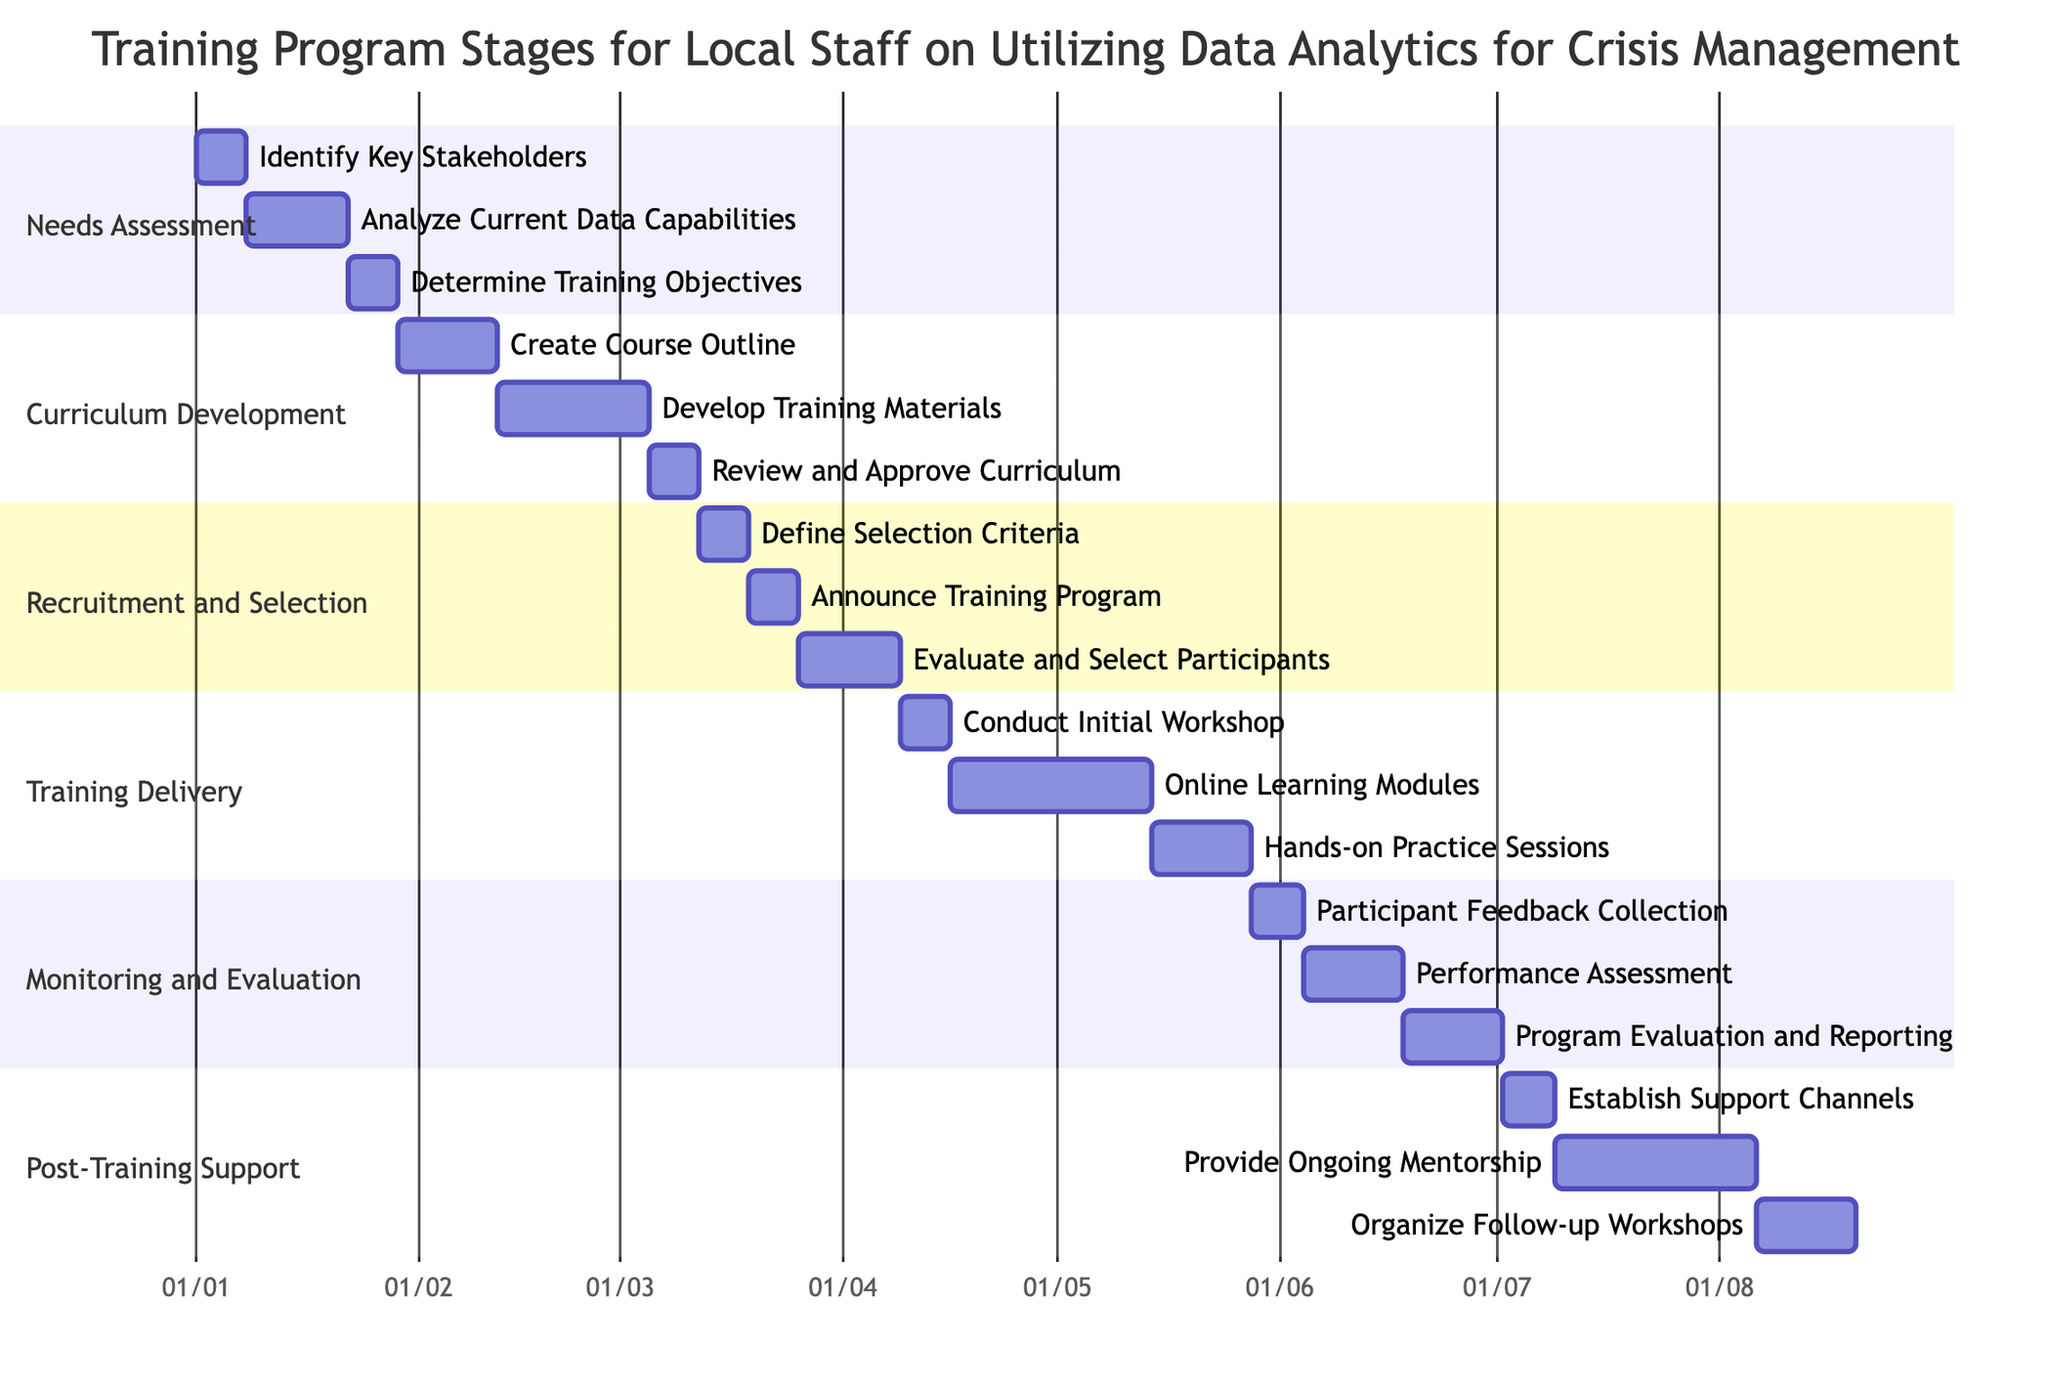What is the duration of the "Analyze Current Data Capabilities" task? The task "Analyze Current Data Capabilities" is listed under the "Needs Assessment" section, and its duration is explicitly stated as "2 weeks."
Answer: 2 weeks How many tasks are included in the "Training Delivery" section? The "Training Delivery" section contains three tasks: "Conduct Initial Workshop," "Online Learning Modules," and "Hands-on Practice Sessions." Thus, the total number of tasks in this section is three.
Answer: 3 Which stage immediately follows "Curriculum Development"? After "Curriculum Development," the next stage is "Recruitment and Selection," as indicated by the flow of tasks in the Gantt chart.
Answer: Recruitment and Selection What is the total duration of the "Post-Training Support" stage? The total duration is calculated by adding the durations of its three tasks: "Establish Support Channels" (1 week), "Provide Ongoing Mentorship" (4 weeks), and "Organize Follow-up Workshops" (2 weeks), which totals to 7 weeks.
Answer: 7 weeks What are the last two tasks of the training program? The last two tasks of the training program, listed in the final section "Post-Training Support," are "Provide Ongoing Mentorship" followed by "Organize Follow-up Workshops."
Answer: Provide Ongoing Mentorship, Organize Follow-up Workshops How many weeks does the "Monitoring and Evaluation" section take in total? The section contains three tasks with durations: "Participant Feedback Collection" (1 week), "Performance Assessment" (2 weeks), and "Program Evaluation and Reporting" (2 weeks). The sum is 1 + 2 + 2, equal to 5 weeks.
Answer: 5 weeks What task follows "Define Selection Criteria"? The task that follows "Define Selection Criteria" is "Announce Training Program" as per the Gantt chart sequence in the "Recruitment and Selection" section.
Answer: Announce Training Program What is the starting task in the "Curriculum Development" phase? The starting task in the "Curriculum Development" phase is "Create Course Outline," which is the first task listed in that section.
Answer: Create Course Outline 